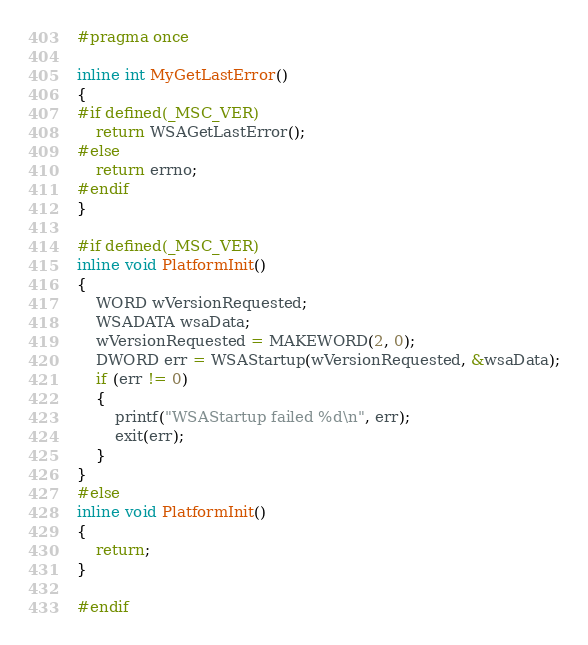Convert code to text. <code><loc_0><loc_0><loc_500><loc_500><_C_>#pragma once

inline int MyGetLastError()
{
#if defined(_MSC_VER)
    return WSAGetLastError();
#else
    return errno;
#endif
}

#if defined(_MSC_VER)
inline void PlatformInit()
{
    WORD wVersionRequested;
    WSADATA wsaData;
    wVersionRequested = MAKEWORD(2, 0);
    DWORD err = WSAStartup(wVersionRequested, &wsaData);
    if (err != 0)
    {
        printf("WSAStartup failed %d\n", err);
        exit(err);
    }
}
#else
inline void PlatformInit()
{
    return;
}

#endif
</code> 